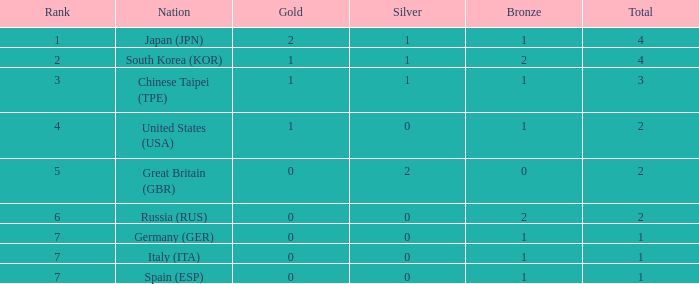What is the rank of the country with more than 2 medals, and 2 gold medals? 1.0. 